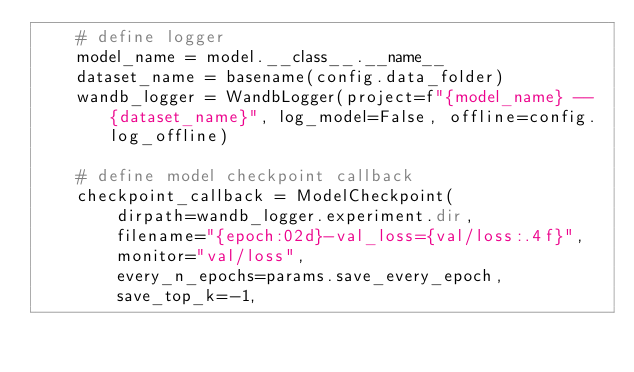<code> <loc_0><loc_0><loc_500><loc_500><_Python_>    # define logger
    model_name = model.__class__.__name__
    dataset_name = basename(config.data_folder)
    wandb_logger = WandbLogger(project=f"{model_name} -- {dataset_name}", log_model=False, offline=config.log_offline)

    # define model checkpoint callback
    checkpoint_callback = ModelCheckpoint(
        dirpath=wandb_logger.experiment.dir,
        filename="{epoch:02d}-val_loss={val/loss:.4f}",
        monitor="val/loss",
        every_n_epochs=params.save_every_epoch,
        save_top_k=-1,</code> 